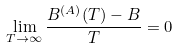Convert formula to latex. <formula><loc_0><loc_0><loc_500><loc_500>\lim _ { T \to \infty } \frac { B ^ { ( A ) } ( T ) - B } { T } = 0</formula> 